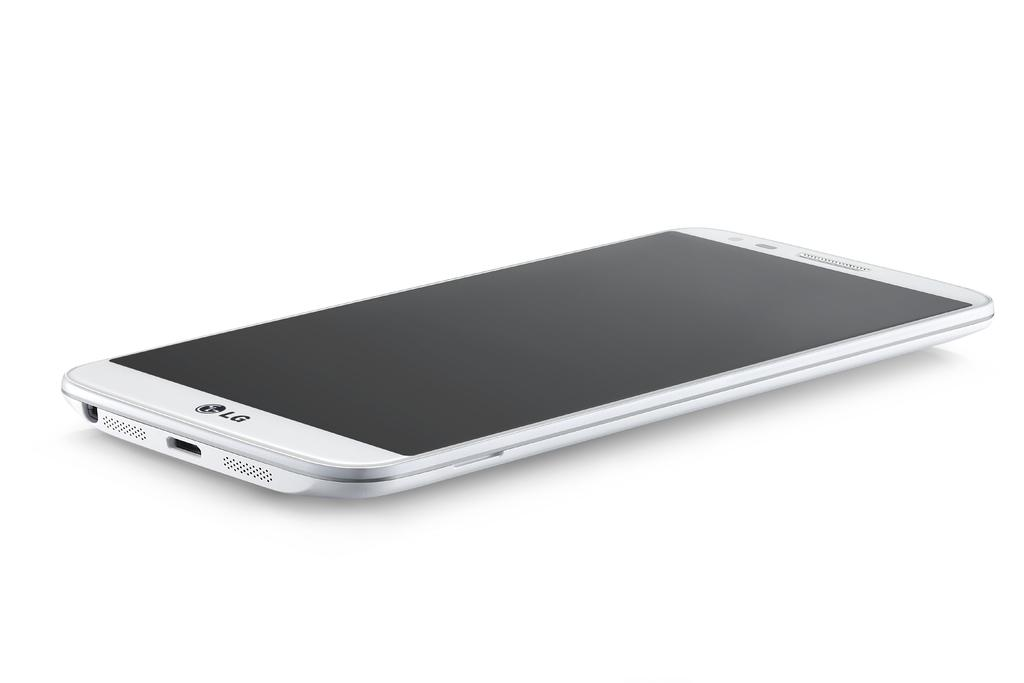<image>
Write a terse but informative summary of the picture. a sleek silver LG phone on a white back ground 